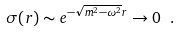<formula> <loc_0><loc_0><loc_500><loc_500>\sigma ( r ) \sim e ^ { - \sqrt { m ^ { 2 } - \omega ^ { 2 } } r } \rightarrow 0 \ .</formula> 